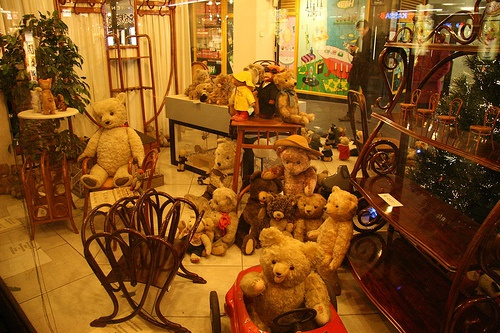Describe the objects in this image and their specific colors. I can see teddy bear in olive, brown, maroon, and orange tones, teddy bear in olive, orange, red, and maroon tones, teddy bear in olive, red, orange, and maroon tones, teddy bear in olive, brown, maroon, and orange tones, and teddy bear in olive, maroon, black, brown, and orange tones in this image. 